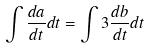Convert formula to latex. <formula><loc_0><loc_0><loc_500><loc_500>\int \frac { d a } { d t } d t = \int 3 \frac { d b } { d t } d t</formula> 